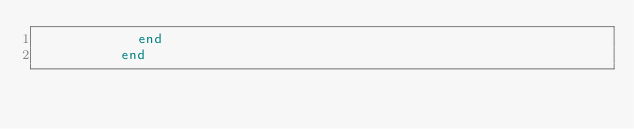Convert code to text. <code><loc_0><loc_0><loc_500><loc_500><_Ruby_>            end
          end
</code> 